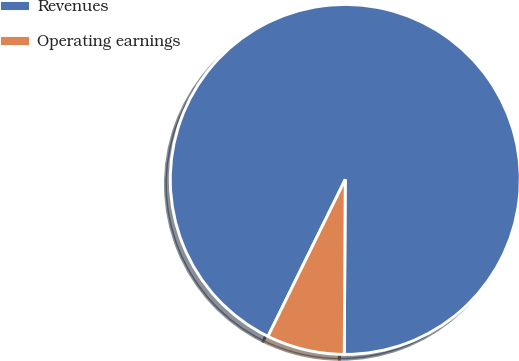Convert chart to OTSL. <chart><loc_0><loc_0><loc_500><loc_500><pie_chart><fcel>Revenues<fcel>Operating earnings<nl><fcel>92.81%<fcel>7.19%<nl></chart> 